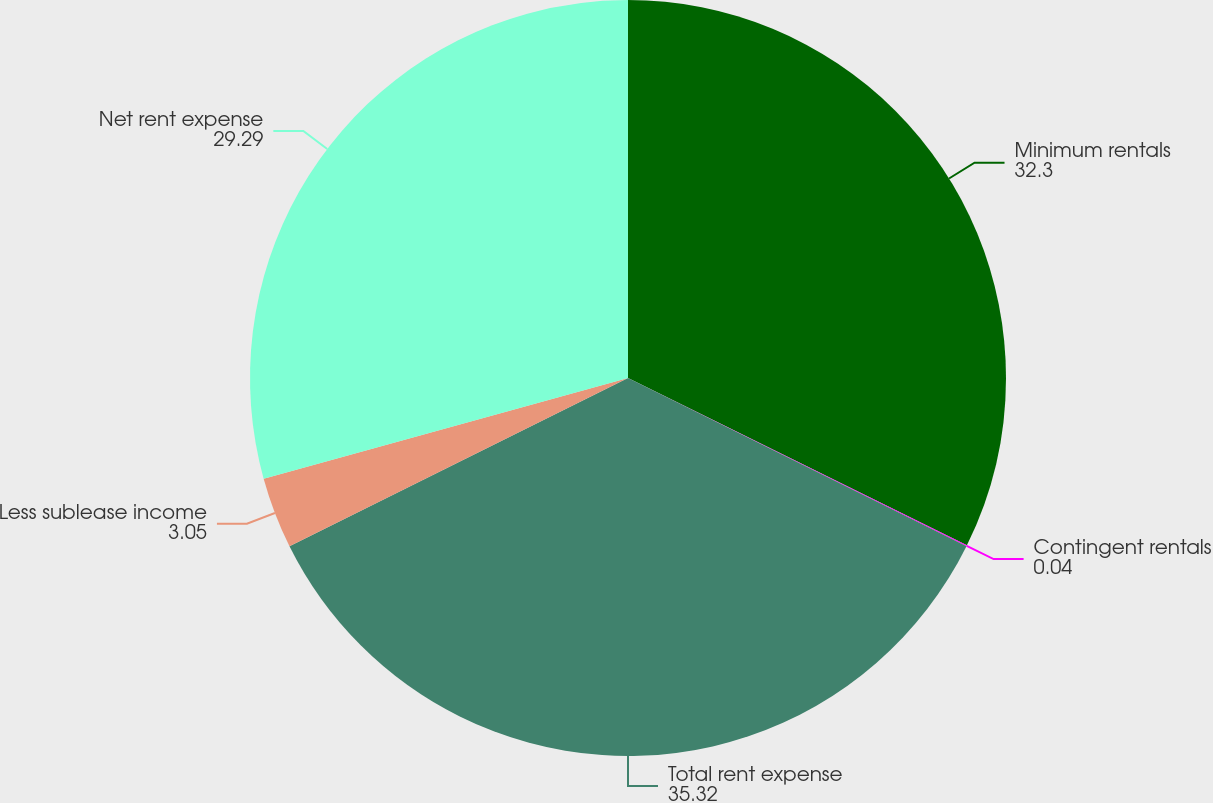Convert chart to OTSL. <chart><loc_0><loc_0><loc_500><loc_500><pie_chart><fcel>Minimum rentals<fcel>Contingent rentals<fcel>Total rent expense<fcel>Less sublease income<fcel>Net rent expense<nl><fcel>32.3%<fcel>0.04%<fcel>35.32%<fcel>3.05%<fcel>29.29%<nl></chart> 